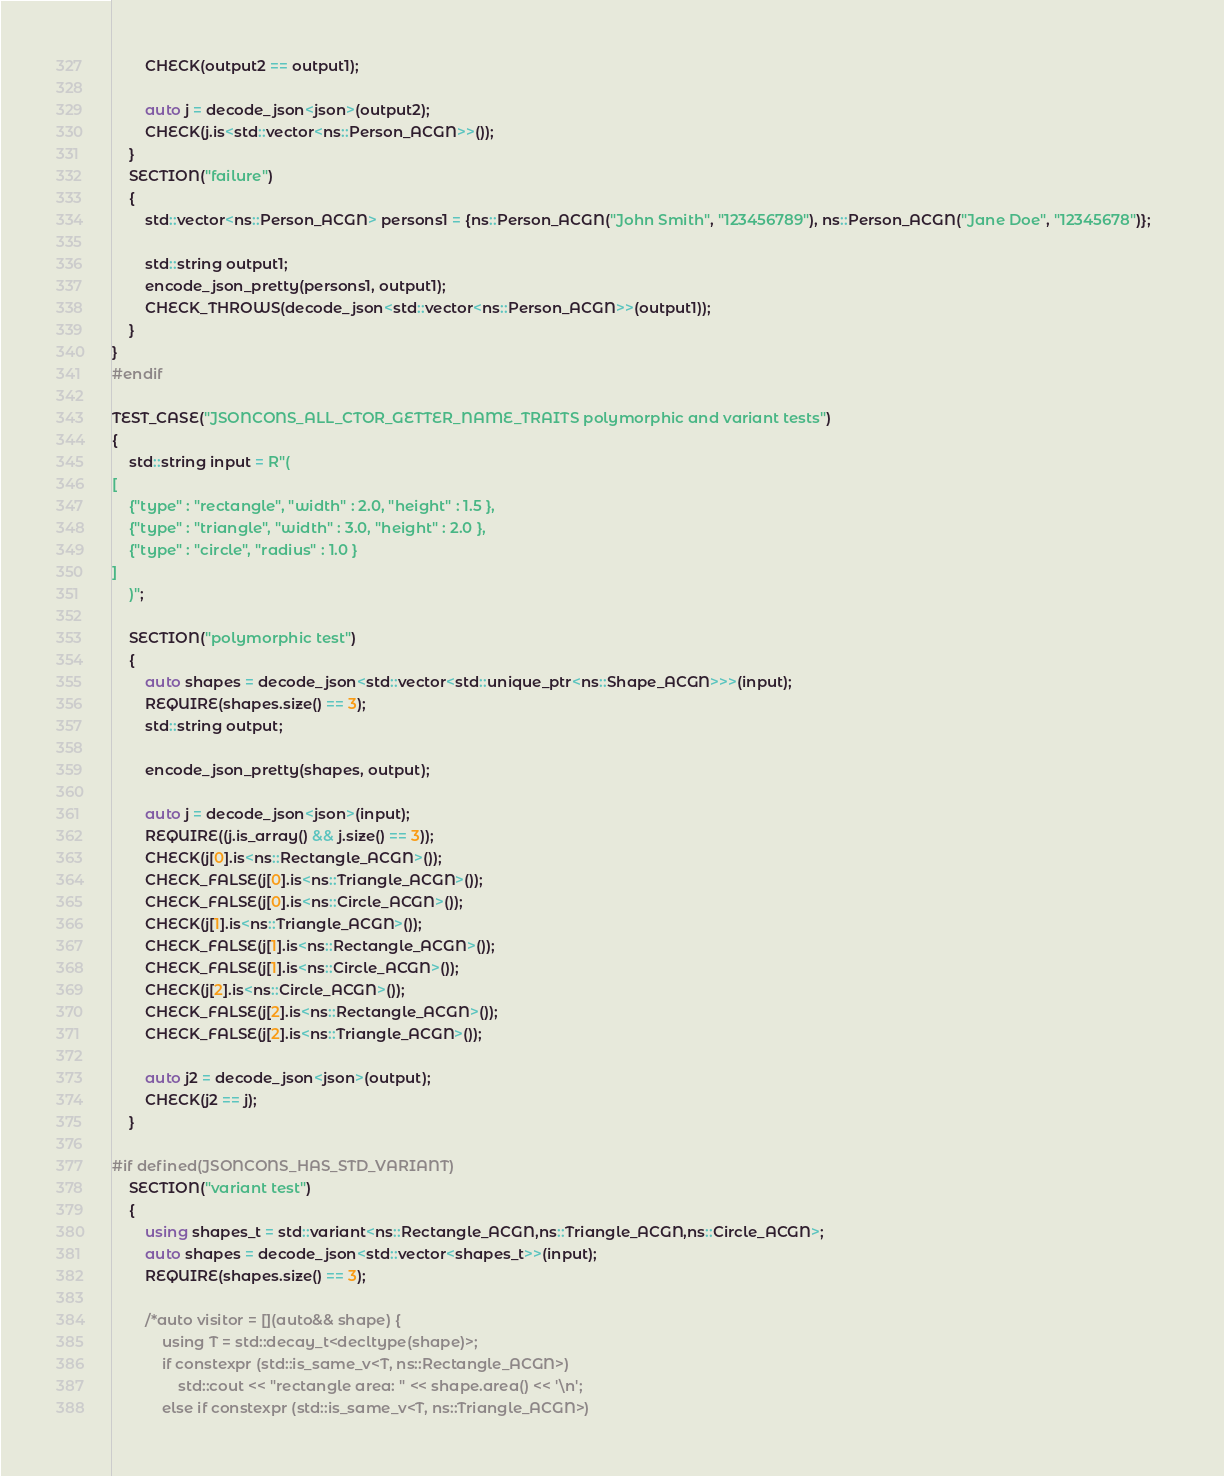Convert code to text. <code><loc_0><loc_0><loc_500><loc_500><_C++_>        CHECK(output2 == output1);

        auto j = decode_json<json>(output2);
        CHECK(j.is<std::vector<ns::Person_ACGN>>());    
    }
    SECTION("failure")
    {
        std::vector<ns::Person_ACGN> persons1 = {ns::Person_ACGN("John Smith", "123456789"), ns::Person_ACGN("Jane Doe", "12345678")};    

        std::string output1;
        encode_json_pretty(persons1, output1);
        CHECK_THROWS(decode_json<std::vector<ns::Person_ACGN>>(output1));
    }
} 
#endif

TEST_CASE("JSONCONS_ALL_CTOR_GETTER_NAME_TRAITS polymorphic and variant tests")
{
    std::string input = R"(
[
    {"type" : "rectangle", "width" : 2.0, "height" : 1.5 },
    {"type" : "triangle", "width" : 3.0, "height" : 2.0 },
    {"type" : "circle", "radius" : 1.0 }
]
    )";

    SECTION("polymorphic test")
    {
        auto shapes = decode_json<std::vector<std::unique_ptr<ns::Shape_ACGN>>>(input);
        REQUIRE(shapes.size() == 3);
        std::string output;

        encode_json_pretty(shapes, output);

        auto j = decode_json<json>(input);
        REQUIRE((j.is_array() && j.size() == 3));
        CHECK(j[0].is<ns::Rectangle_ACGN>());
        CHECK_FALSE(j[0].is<ns::Triangle_ACGN>());
        CHECK_FALSE(j[0].is<ns::Circle_ACGN>());
        CHECK(j[1].is<ns::Triangle_ACGN>());
        CHECK_FALSE(j[1].is<ns::Rectangle_ACGN>());
        CHECK_FALSE(j[1].is<ns::Circle_ACGN>());
        CHECK(j[2].is<ns::Circle_ACGN>());
        CHECK_FALSE(j[2].is<ns::Rectangle_ACGN>());
        CHECK_FALSE(j[2].is<ns::Triangle_ACGN>());

        auto j2 = decode_json<json>(output);
        CHECK(j2 == j);
    }

#if defined(JSONCONS_HAS_STD_VARIANT)
    SECTION("variant test")
    {
        using shapes_t = std::variant<ns::Rectangle_ACGN,ns::Triangle_ACGN,ns::Circle_ACGN>;
        auto shapes = decode_json<std::vector<shapes_t>>(input);
        REQUIRE(shapes.size() == 3);

        /*auto visitor = [](auto&& shape) {
            using T = std::decay_t<decltype(shape)>;
            if constexpr (std::is_same_v<T, ns::Rectangle_ACGN>)
                std::cout << "rectangle area: " << shape.area() << '\n';
            else if constexpr (std::is_same_v<T, ns::Triangle_ACGN>)</code> 